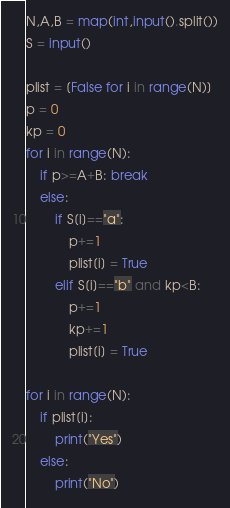Convert code to text. <code><loc_0><loc_0><loc_500><loc_500><_Python_>N,A,B = map(int,input().split())
S = input()

plist = [False for i in range(N)]
p = 0
kp = 0
for i in range(N):
    if p>=A+B: break
    else:
        if S[i]=="a":
            p+=1
            plist[i] = True
        elif S[i]=="b" and kp<B:
            p+=1
            kp+=1
            plist[i] = True
            
for i in range(N):
    if plist[i]:
        print("Yes")
    else:
        print("No")</code> 